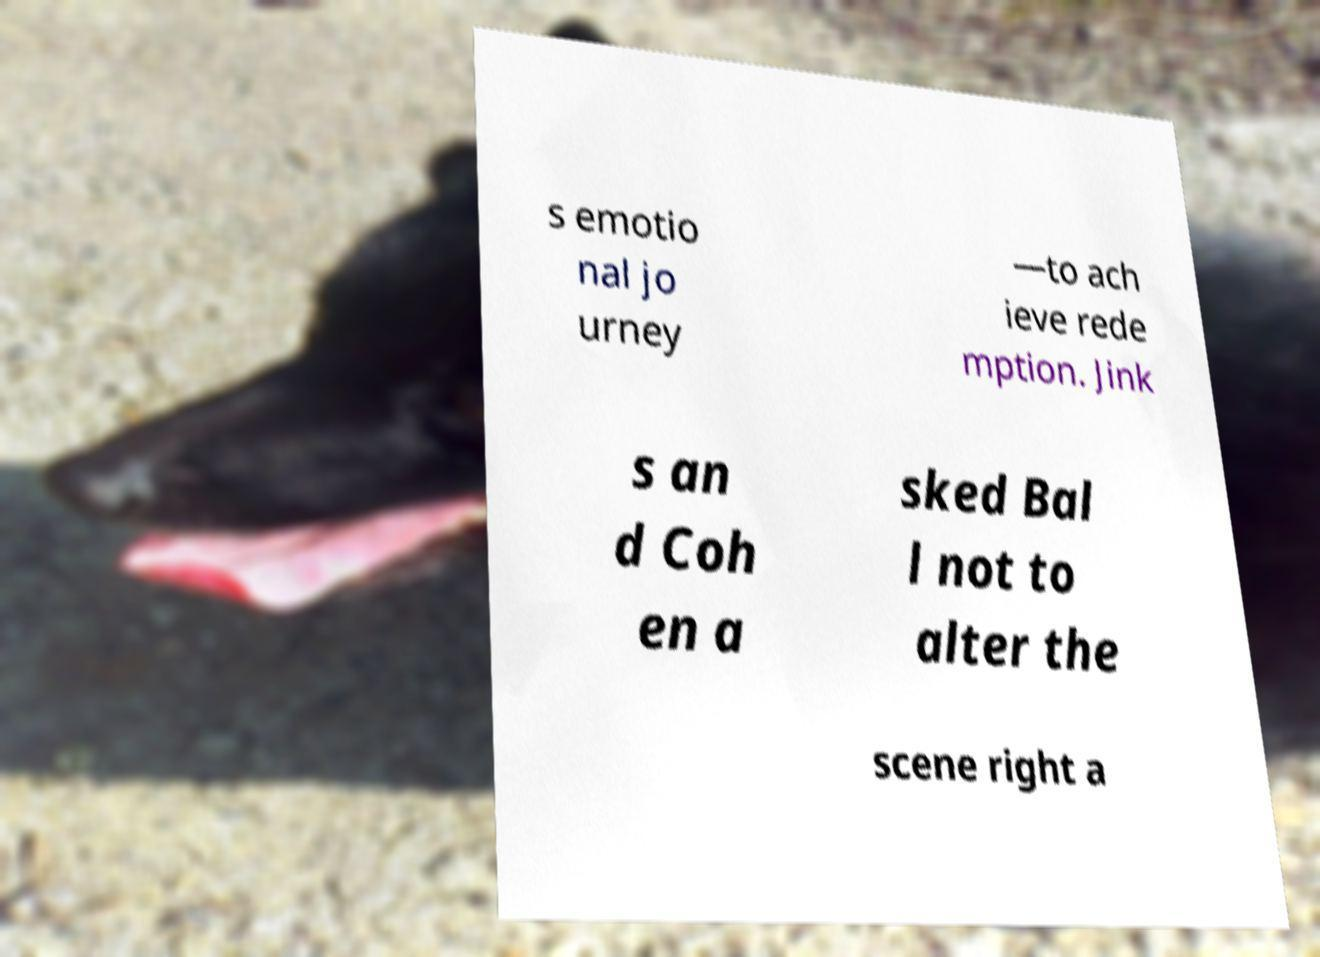Could you extract and type out the text from this image? s emotio nal jo urney —to ach ieve rede mption. Jink s an d Coh en a sked Bal l not to alter the scene right a 